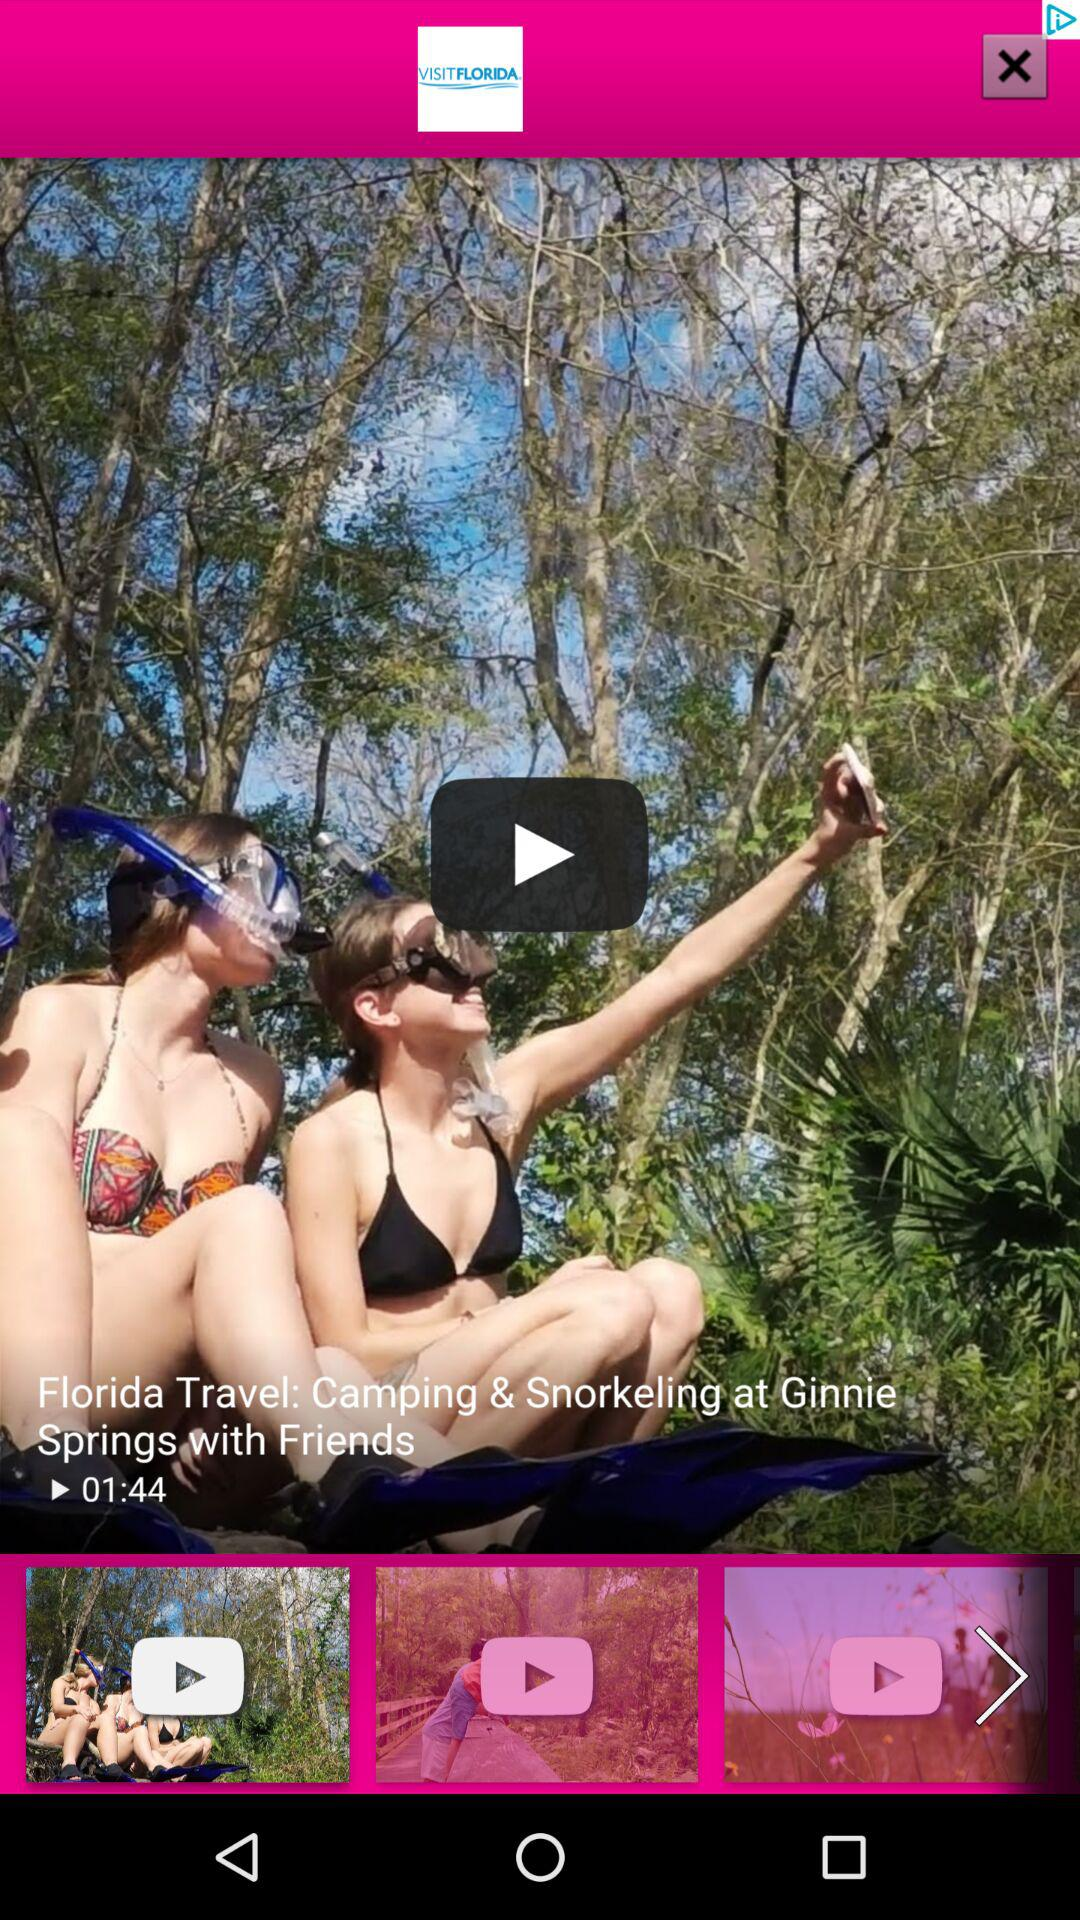What is the name of the application? The name of the application is "VISITFLORIDA". 